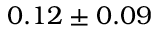<formula> <loc_0><loc_0><loc_500><loc_500>0 . 1 2 \pm 0 . 0 9</formula> 